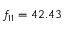<formula> <loc_0><loc_0><loc_500><loc_500>f _ { 1 1 } = 4 2 . 4 3</formula> 